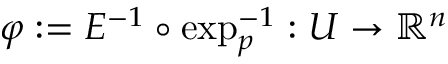<formula> <loc_0><loc_0><loc_500><loc_500>\varphi \colon = E ^ { - 1 } \circ \exp _ { p } ^ { - 1 } \colon U \rightarrow \mathbb { R } ^ { n }</formula> 